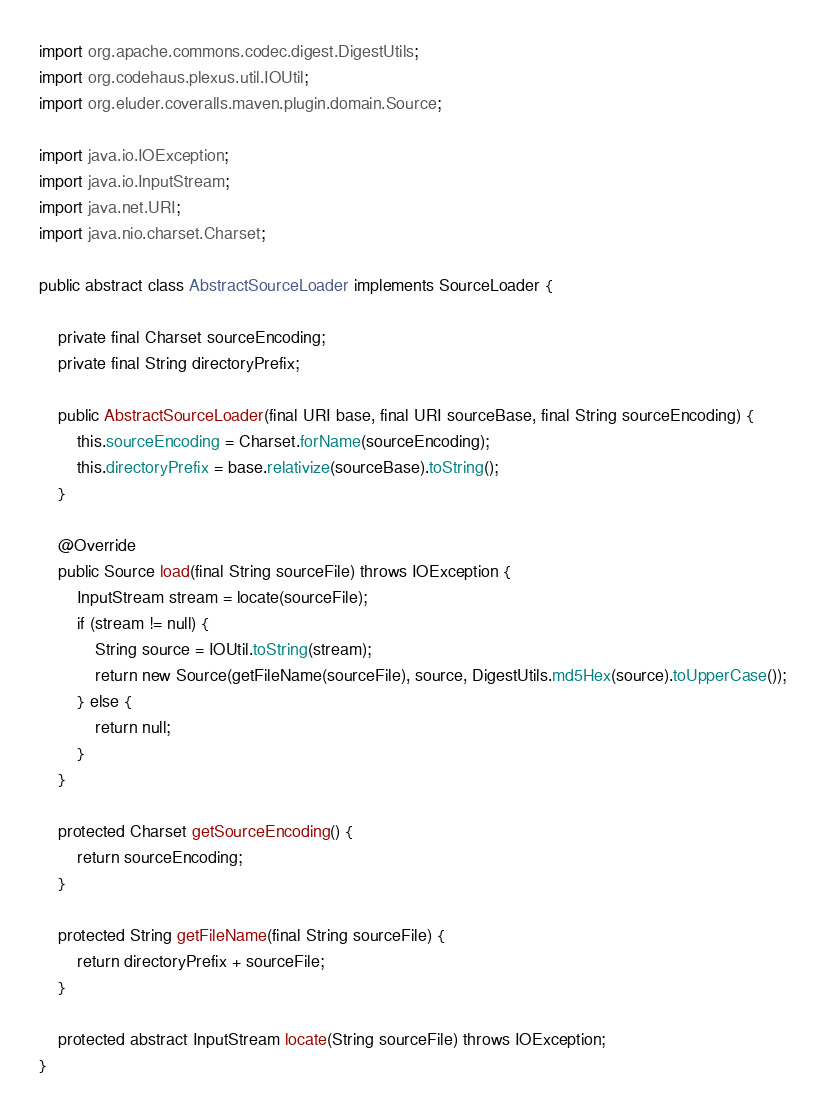<code> <loc_0><loc_0><loc_500><loc_500><_Java_>
import org.apache.commons.codec.digest.DigestUtils;
import org.codehaus.plexus.util.IOUtil;
import org.eluder.coveralls.maven.plugin.domain.Source;

import java.io.IOException;
import java.io.InputStream;
import java.net.URI;
import java.nio.charset.Charset;

public abstract class AbstractSourceLoader implements SourceLoader {

    private final Charset sourceEncoding;
    private final String directoryPrefix;
    
    public AbstractSourceLoader(final URI base, final URI sourceBase, final String sourceEncoding) {
        this.sourceEncoding = Charset.forName(sourceEncoding);
        this.directoryPrefix = base.relativize(sourceBase).toString();
    }
    
    @Override
    public Source load(final String sourceFile) throws IOException {
        InputStream stream = locate(sourceFile);
        if (stream != null) {
            String source = IOUtil.toString(stream);
            return new Source(getFileName(sourceFile), source, DigestUtils.md5Hex(source).toUpperCase());
        } else {
            return null;
        }
    }
    
    protected Charset getSourceEncoding() {
        return sourceEncoding;
    }
    
    protected String getFileName(final String sourceFile) {
        return directoryPrefix + sourceFile;
    }
    
    protected abstract InputStream locate(String sourceFile) throws IOException;
}
</code> 